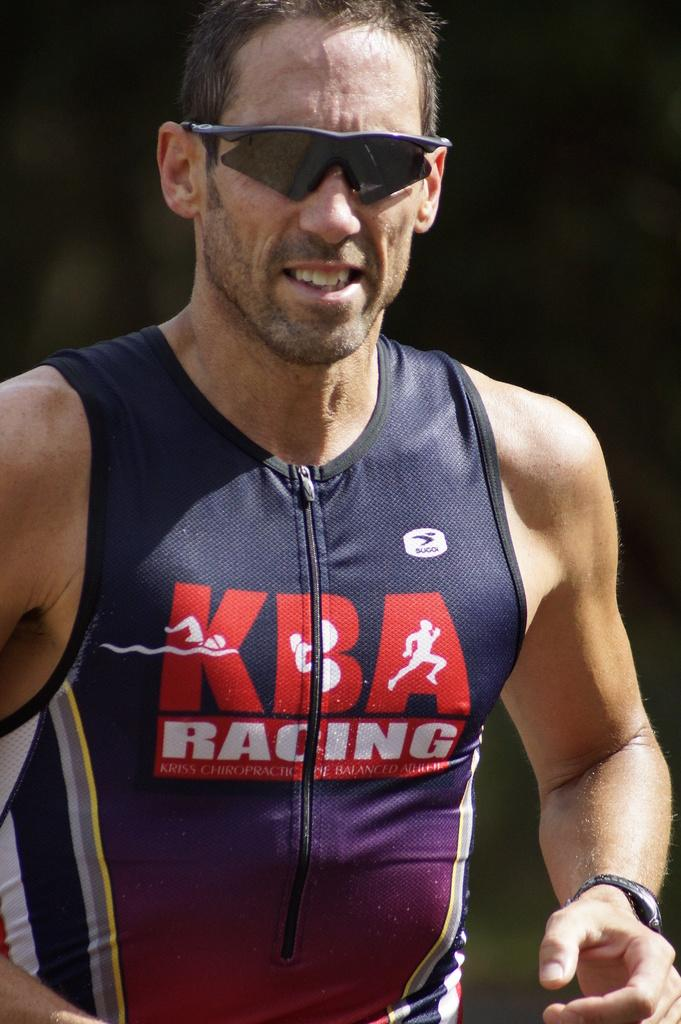Provide a one-sentence caption for the provided image. A runner wearing a shirt that states KBA Racing. 